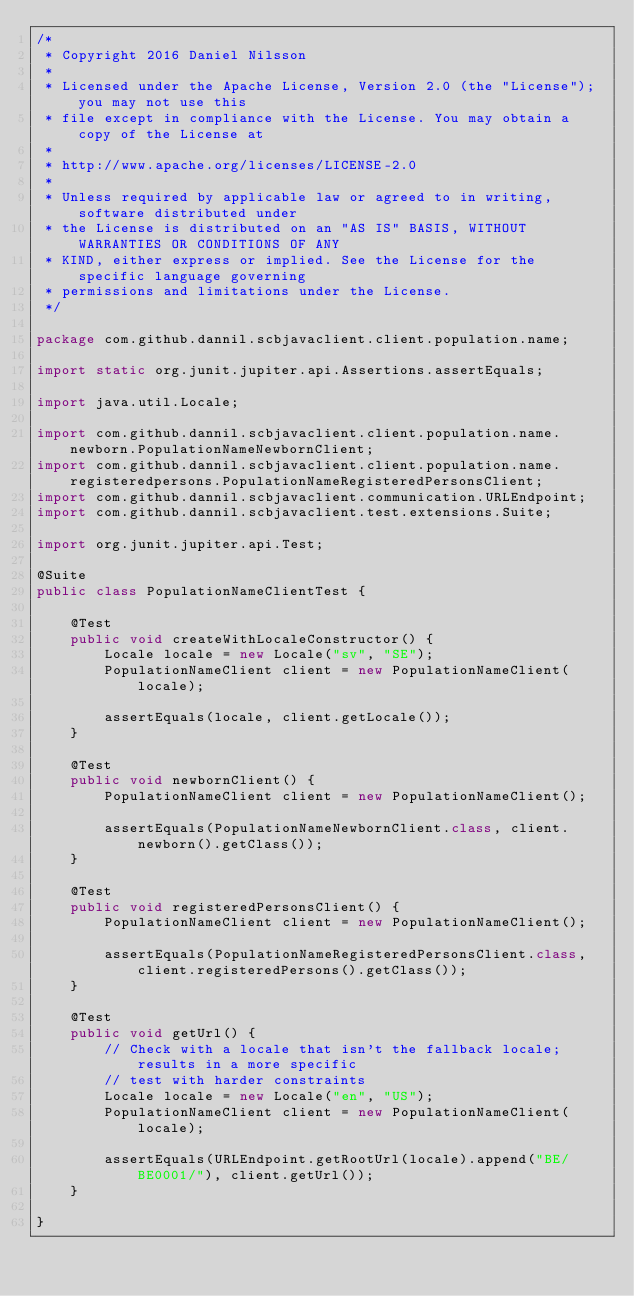Convert code to text. <code><loc_0><loc_0><loc_500><loc_500><_Java_>/*
 * Copyright 2016 Daniel Nilsson
 *
 * Licensed under the Apache License, Version 2.0 (the "License"); you may not use this
 * file except in compliance with the License. You may obtain a copy of the License at
 *
 * http://www.apache.org/licenses/LICENSE-2.0
 *
 * Unless required by applicable law or agreed to in writing, software distributed under
 * the License is distributed on an "AS IS" BASIS, WITHOUT WARRANTIES OR CONDITIONS OF ANY
 * KIND, either express or implied. See the License for the specific language governing
 * permissions and limitations under the License.
 */

package com.github.dannil.scbjavaclient.client.population.name;

import static org.junit.jupiter.api.Assertions.assertEquals;

import java.util.Locale;

import com.github.dannil.scbjavaclient.client.population.name.newborn.PopulationNameNewbornClient;
import com.github.dannil.scbjavaclient.client.population.name.registeredpersons.PopulationNameRegisteredPersonsClient;
import com.github.dannil.scbjavaclient.communication.URLEndpoint;
import com.github.dannil.scbjavaclient.test.extensions.Suite;

import org.junit.jupiter.api.Test;

@Suite
public class PopulationNameClientTest {

    @Test
    public void createWithLocaleConstructor() {
        Locale locale = new Locale("sv", "SE");
        PopulationNameClient client = new PopulationNameClient(locale);

        assertEquals(locale, client.getLocale());
    }

    @Test
    public void newbornClient() {
        PopulationNameClient client = new PopulationNameClient();

        assertEquals(PopulationNameNewbornClient.class, client.newborn().getClass());
    }

    @Test
    public void registeredPersonsClient() {
        PopulationNameClient client = new PopulationNameClient();

        assertEquals(PopulationNameRegisteredPersonsClient.class, client.registeredPersons().getClass());
    }

    @Test
    public void getUrl() {
        // Check with a locale that isn't the fallback locale; results in a more specific
        // test with harder constraints
        Locale locale = new Locale("en", "US");
        PopulationNameClient client = new PopulationNameClient(locale);

        assertEquals(URLEndpoint.getRootUrl(locale).append("BE/BE0001/"), client.getUrl());
    }

}
</code> 